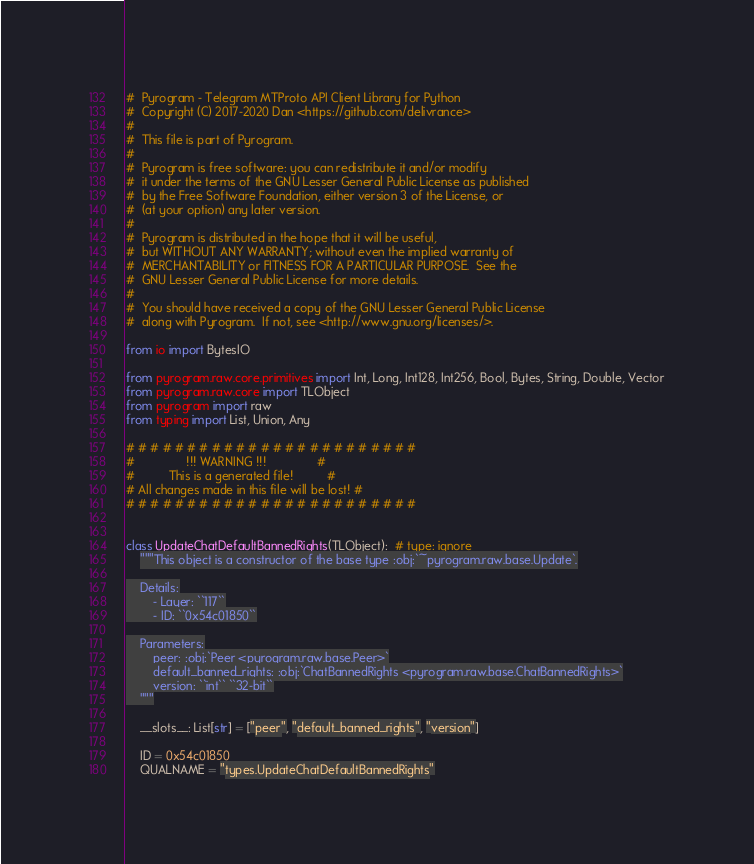<code> <loc_0><loc_0><loc_500><loc_500><_Python_>#  Pyrogram - Telegram MTProto API Client Library for Python
#  Copyright (C) 2017-2020 Dan <https://github.com/delivrance>
#
#  This file is part of Pyrogram.
#
#  Pyrogram is free software: you can redistribute it and/or modify
#  it under the terms of the GNU Lesser General Public License as published
#  by the Free Software Foundation, either version 3 of the License, or
#  (at your option) any later version.
#
#  Pyrogram is distributed in the hope that it will be useful,
#  but WITHOUT ANY WARRANTY; without even the implied warranty of
#  MERCHANTABILITY or FITNESS FOR A PARTICULAR PURPOSE.  See the
#  GNU Lesser General Public License for more details.
#
#  You should have received a copy of the GNU Lesser General Public License
#  along with Pyrogram.  If not, see <http://www.gnu.org/licenses/>.

from io import BytesIO

from pyrogram.raw.core.primitives import Int, Long, Int128, Int256, Bool, Bytes, String, Double, Vector
from pyrogram.raw.core import TLObject
from pyrogram import raw
from typing import List, Union, Any

# # # # # # # # # # # # # # # # # # # # # # # #
#               !!! WARNING !!!               #
#          This is a generated file!          #
# All changes made in this file will be lost! #
# # # # # # # # # # # # # # # # # # # # # # # #


class UpdateChatDefaultBannedRights(TLObject):  # type: ignore
    """This object is a constructor of the base type :obj:`~pyrogram.raw.base.Update`.

    Details:
        - Layer: ``117``
        - ID: ``0x54c01850``

    Parameters:
        peer: :obj:`Peer <pyrogram.raw.base.Peer>`
        default_banned_rights: :obj:`ChatBannedRights <pyrogram.raw.base.ChatBannedRights>`
        version: ``int`` ``32-bit``
    """

    __slots__: List[str] = ["peer", "default_banned_rights", "version"]

    ID = 0x54c01850
    QUALNAME = "types.UpdateChatDefaultBannedRights"
</code> 